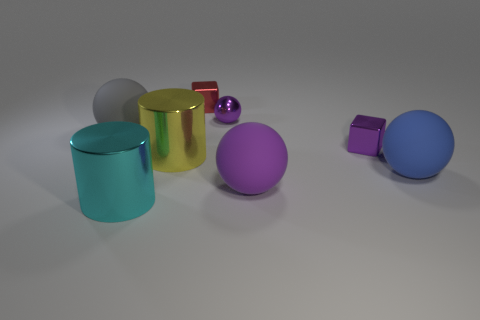What number of things are red metal things that are behind the big purple matte ball or red shiny things?
Make the answer very short. 1. Is there a tiny metallic cube that has the same color as the metal sphere?
Make the answer very short. Yes. There is a tiny red shiny thing; is its shape the same as the big yellow thing behind the big purple thing?
Your response must be concise. No. How many rubber spheres are both in front of the yellow thing and to the left of the blue thing?
Ensure brevity in your answer.  1. What material is the big purple object that is the same shape as the large gray rubber thing?
Make the answer very short. Rubber. There is a matte sphere that is on the left side of the small metallic cube that is on the left side of the tiny purple metallic ball; what is its size?
Make the answer very short. Large. Are there any large brown metallic cubes?
Keep it short and to the point. No. There is a big object that is both in front of the big blue thing and behind the big cyan shiny object; what is it made of?
Your answer should be compact. Rubber. Is the number of spheres that are to the left of the large purple matte object greater than the number of red blocks that are in front of the small purple shiny block?
Keep it short and to the point. Yes. Are there any shiny blocks that have the same size as the cyan object?
Keep it short and to the point. No. 